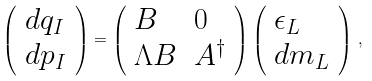Convert formula to latex. <formula><loc_0><loc_0><loc_500><loc_500>\left ( \begin{array} { l } d q _ { I } \\ d p _ { I } \end{array} \right ) = \left ( \begin{array} { l l } B & 0 \\ \Lambda B & A ^ { \dagger } \end{array} \right ) \left ( \begin{array} { l } \epsilon _ { L } \\ d m _ { L } \end{array} \right ) \, ,</formula> 